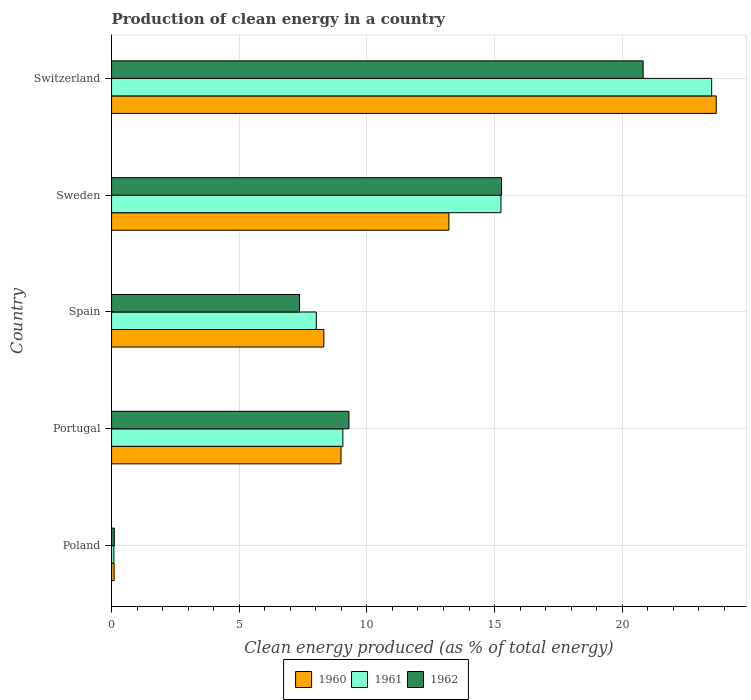How many bars are there on the 2nd tick from the top?
Your response must be concise. 3. In how many cases, is the number of bars for a given country not equal to the number of legend labels?
Your answer should be compact. 0. What is the percentage of clean energy produced in 1960 in Poland?
Provide a short and direct response. 0.1. Across all countries, what is the maximum percentage of clean energy produced in 1960?
Offer a terse response. 23.68. Across all countries, what is the minimum percentage of clean energy produced in 1961?
Your answer should be very brief. 0.09. In which country was the percentage of clean energy produced in 1960 maximum?
Provide a short and direct response. Switzerland. What is the total percentage of clean energy produced in 1960 in the graph?
Keep it short and to the point. 54.29. What is the difference between the percentage of clean energy produced in 1962 in Portugal and that in Sweden?
Keep it short and to the point. -5.98. What is the difference between the percentage of clean energy produced in 1962 in Poland and the percentage of clean energy produced in 1961 in Sweden?
Give a very brief answer. -15.14. What is the average percentage of clean energy produced in 1960 per country?
Your response must be concise. 10.86. What is the difference between the percentage of clean energy produced in 1961 and percentage of clean energy produced in 1962 in Switzerland?
Provide a short and direct response. 2.68. In how many countries, is the percentage of clean energy produced in 1960 greater than 15 %?
Give a very brief answer. 1. What is the ratio of the percentage of clean energy produced in 1961 in Poland to that in Switzerland?
Make the answer very short. 0. Is the difference between the percentage of clean energy produced in 1961 in Portugal and Switzerland greater than the difference between the percentage of clean energy produced in 1962 in Portugal and Switzerland?
Your answer should be compact. No. What is the difference between the highest and the second highest percentage of clean energy produced in 1960?
Provide a succinct answer. 10.47. What is the difference between the highest and the lowest percentage of clean energy produced in 1961?
Your response must be concise. 23.41. In how many countries, is the percentage of clean energy produced in 1962 greater than the average percentage of clean energy produced in 1962 taken over all countries?
Give a very brief answer. 2. What does the 3rd bar from the bottom in Switzerland represents?
Make the answer very short. 1962. Is it the case that in every country, the sum of the percentage of clean energy produced in 1962 and percentage of clean energy produced in 1960 is greater than the percentage of clean energy produced in 1961?
Your response must be concise. Yes. Are all the bars in the graph horizontal?
Offer a terse response. Yes. How many countries are there in the graph?
Offer a terse response. 5. What is the difference between two consecutive major ticks on the X-axis?
Provide a short and direct response. 5. Are the values on the major ticks of X-axis written in scientific E-notation?
Offer a terse response. No. Does the graph contain grids?
Give a very brief answer. Yes. Where does the legend appear in the graph?
Your answer should be compact. Bottom center. How many legend labels are there?
Your response must be concise. 3. How are the legend labels stacked?
Provide a short and direct response. Horizontal. What is the title of the graph?
Your response must be concise. Production of clean energy in a country. Does "1997" appear as one of the legend labels in the graph?
Ensure brevity in your answer.  No. What is the label or title of the X-axis?
Your answer should be compact. Clean energy produced (as % of total energy). What is the Clean energy produced (as % of total energy) in 1960 in Poland?
Make the answer very short. 0.1. What is the Clean energy produced (as % of total energy) of 1961 in Poland?
Offer a terse response. 0.09. What is the Clean energy produced (as % of total energy) in 1962 in Poland?
Your answer should be compact. 0.11. What is the Clean energy produced (as % of total energy) in 1960 in Portugal?
Offer a very short reply. 8.99. What is the Clean energy produced (as % of total energy) in 1961 in Portugal?
Keep it short and to the point. 9.06. What is the Clean energy produced (as % of total energy) of 1962 in Portugal?
Give a very brief answer. 9.3. What is the Clean energy produced (as % of total energy) of 1960 in Spain?
Provide a succinct answer. 8.31. What is the Clean energy produced (as % of total energy) of 1961 in Spain?
Keep it short and to the point. 8.02. What is the Clean energy produced (as % of total energy) of 1962 in Spain?
Ensure brevity in your answer.  7.36. What is the Clean energy produced (as % of total energy) in 1960 in Sweden?
Provide a short and direct response. 13.21. What is the Clean energy produced (as % of total energy) of 1961 in Sweden?
Give a very brief answer. 15.25. What is the Clean energy produced (as % of total energy) of 1962 in Sweden?
Make the answer very short. 15.27. What is the Clean energy produced (as % of total energy) of 1960 in Switzerland?
Your answer should be very brief. 23.68. What is the Clean energy produced (as % of total energy) in 1961 in Switzerland?
Your response must be concise. 23.5. What is the Clean energy produced (as % of total energy) in 1962 in Switzerland?
Your response must be concise. 20.82. Across all countries, what is the maximum Clean energy produced (as % of total energy) of 1960?
Ensure brevity in your answer.  23.68. Across all countries, what is the maximum Clean energy produced (as % of total energy) in 1961?
Ensure brevity in your answer.  23.5. Across all countries, what is the maximum Clean energy produced (as % of total energy) of 1962?
Make the answer very short. 20.82. Across all countries, what is the minimum Clean energy produced (as % of total energy) in 1960?
Ensure brevity in your answer.  0.1. Across all countries, what is the minimum Clean energy produced (as % of total energy) in 1961?
Make the answer very short. 0.09. Across all countries, what is the minimum Clean energy produced (as % of total energy) in 1962?
Give a very brief answer. 0.11. What is the total Clean energy produced (as % of total energy) in 1960 in the graph?
Your response must be concise. 54.29. What is the total Clean energy produced (as % of total energy) of 1961 in the graph?
Your answer should be compact. 55.92. What is the total Clean energy produced (as % of total energy) of 1962 in the graph?
Offer a terse response. 52.86. What is the difference between the Clean energy produced (as % of total energy) in 1960 in Poland and that in Portugal?
Provide a short and direct response. -8.88. What is the difference between the Clean energy produced (as % of total energy) of 1961 in Poland and that in Portugal?
Make the answer very short. -8.97. What is the difference between the Clean energy produced (as % of total energy) in 1962 in Poland and that in Portugal?
Provide a succinct answer. -9.19. What is the difference between the Clean energy produced (as % of total energy) of 1960 in Poland and that in Spain?
Ensure brevity in your answer.  -8.21. What is the difference between the Clean energy produced (as % of total energy) of 1961 in Poland and that in Spain?
Offer a terse response. -7.93. What is the difference between the Clean energy produced (as % of total energy) of 1962 in Poland and that in Spain?
Your answer should be compact. -7.25. What is the difference between the Clean energy produced (as % of total energy) of 1960 in Poland and that in Sweden?
Make the answer very short. -13.11. What is the difference between the Clean energy produced (as % of total energy) in 1961 in Poland and that in Sweden?
Give a very brief answer. -15.16. What is the difference between the Clean energy produced (as % of total energy) of 1962 in Poland and that in Sweden?
Your response must be concise. -15.17. What is the difference between the Clean energy produced (as % of total energy) of 1960 in Poland and that in Switzerland?
Give a very brief answer. -23.58. What is the difference between the Clean energy produced (as % of total energy) of 1961 in Poland and that in Switzerland?
Offer a very short reply. -23.41. What is the difference between the Clean energy produced (as % of total energy) in 1962 in Poland and that in Switzerland?
Offer a terse response. -20.71. What is the difference between the Clean energy produced (as % of total energy) in 1960 in Portugal and that in Spain?
Offer a very short reply. 0.67. What is the difference between the Clean energy produced (as % of total energy) of 1961 in Portugal and that in Spain?
Your response must be concise. 1.04. What is the difference between the Clean energy produced (as % of total energy) of 1962 in Portugal and that in Spain?
Keep it short and to the point. 1.94. What is the difference between the Clean energy produced (as % of total energy) of 1960 in Portugal and that in Sweden?
Your response must be concise. -4.23. What is the difference between the Clean energy produced (as % of total energy) in 1961 in Portugal and that in Sweden?
Offer a very short reply. -6.19. What is the difference between the Clean energy produced (as % of total energy) of 1962 in Portugal and that in Sweden?
Make the answer very short. -5.98. What is the difference between the Clean energy produced (as % of total energy) of 1960 in Portugal and that in Switzerland?
Ensure brevity in your answer.  -14.7. What is the difference between the Clean energy produced (as % of total energy) of 1961 in Portugal and that in Switzerland?
Offer a terse response. -14.44. What is the difference between the Clean energy produced (as % of total energy) of 1962 in Portugal and that in Switzerland?
Offer a terse response. -11.52. What is the difference between the Clean energy produced (as % of total energy) of 1960 in Spain and that in Sweden?
Your response must be concise. -4.9. What is the difference between the Clean energy produced (as % of total energy) of 1961 in Spain and that in Sweden?
Your answer should be very brief. -7.23. What is the difference between the Clean energy produced (as % of total energy) in 1962 in Spain and that in Sweden?
Offer a very short reply. -7.91. What is the difference between the Clean energy produced (as % of total energy) in 1960 in Spain and that in Switzerland?
Your answer should be compact. -15.37. What is the difference between the Clean energy produced (as % of total energy) of 1961 in Spain and that in Switzerland?
Ensure brevity in your answer.  -15.48. What is the difference between the Clean energy produced (as % of total energy) of 1962 in Spain and that in Switzerland?
Give a very brief answer. -13.46. What is the difference between the Clean energy produced (as % of total energy) of 1960 in Sweden and that in Switzerland?
Your answer should be compact. -10.47. What is the difference between the Clean energy produced (as % of total energy) in 1961 in Sweden and that in Switzerland?
Provide a succinct answer. -8.25. What is the difference between the Clean energy produced (as % of total energy) of 1962 in Sweden and that in Switzerland?
Provide a short and direct response. -5.55. What is the difference between the Clean energy produced (as % of total energy) of 1960 in Poland and the Clean energy produced (as % of total energy) of 1961 in Portugal?
Keep it short and to the point. -8.96. What is the difference between the Clean energy produced (as % of total energy) in 1960 in Poland and the Clean energy produced (as % of total energy) in 1962 in Portugal?
Give a very brief answer. -9.2. What is the difference between the Clean energy produced (as % of total energy) of 1961 in Poland and the Clean energy produced (as % of total energy) of 1962 in Portugal?
Make the answer very short. -9.21. What is the difference between the Clean energy produced (as % of total energy) in 1960 in Poland and the Clean energy produced (as % of total energy) in 1961 in Spain?
Your response must be concise. -7.92. What is the difference between the Clean energy produced (as % of total energy) of 1960 in Poland and the Clean energy produced (as % of total energy) of 1962 in Spain?
Provide a succinct answer. -7.26. What is the difference between the Clean energy produced (as % of total energy) in 1961 in Poland and the Clean energy produced (as % of total energy) in 1962 in Spain?
Give a very brief answer. -7.27. What is the difference between the Clean energy produced (as % of total energy) of 1960 in Poland and the Clean energy produced (as % of total energy) of 1961 in Sweden?
Offer a terse response. -15.15. What is the difference between the Clean energy produced (as % of total energy) of 1960 in Poland and the Clean energy produced (as % of total energy) of 1962 in Sweden?
Make the answer very short. -15.17. What is the difference between the Clean energy produced (as % of total energy) of 1961 in Poland and the Clean energy produced (as % of total energy) of 1962 in Sweden?
Make the answer very short. -15.18. What is the difference between the Clean energy produced (as % of total energy) in 1960 in Poland and the Clean energy produced (as % of total energy) in 1961 in Switzerland?
Keep it short and to the point. -23.4. What is the difference between the Clean energy produced (as % of total energy) in 1960 in Poland and the Clean energy produced (as % of total energy) in 1962 in Switzerland?
Your answer should be compact. -20.72. What is the difference between the Clean energy produced (as % of total energy) of 1961 in Poland and the Clean energy produced (as % of total energy) of 1962 in Switzerland?
Ensure brevity in your answer.  -20.73. What is the difference between the Clean energy produced (as % of total energy) of 1960 in Portugal and the Clean energy produced (as % of total energy) of 1961 in Spain?
Provide a short and direct response. 0.97. What is the difference between the Clean energy produced (as % of total energy) in 1960 in Portugal and the Clean energy produced (as % of total energy) in 1962 in Spain?
Your answer should be very brief. 1.62. What is the difference between the Clean energy produced (as % of total energy) in 1961 in Portugal and the Clean energy produced (as % of total energy) in 1962 in Spain?
Ensure brevity in your answer.  1.7. What is the difference between the Clean energy produced (as % of total energy) in 1960 in Portugal and the Clean energy produced (as % of total energy) in 1961 in Sweden?
Ensure brevity in your answer.  -6.26. What is the difference between the Clean energy produced (as % of total energy) in 1960 in Portugal and the Clean energy produced (as % of total energy) in 1962 in Sweden?
Your answer should be very brief. -6.29. What is the difference between the Clean energy produced (as % of total energy) of 1961 in Portugal and the Clean energy produced (as % of total energy) of 1962 in Sweden?
Provide a succinct answer. -6.21. What is the difference between the Clean energy produced (as % of total energy) of 1960 in Portugal and the Clean energy produced (as % of total energy) of 1961 in Switzerland?
Offer a very short reply. -14.52. What is the difference between the Clean energy produced (as % of total energy) of 1960 in Portugal and the Clean energy produced (as % of total energy) of 1962 in Switzerland?
Your response must be concise. -11.83. What is the difference between the Clean energy produced (as % of total energy) in 1961 in Portugal and the Clean energy produced (as % of total energy) in 1962 in Switzerland?
Offer a very short reply. -11.76. What is the difference between the Clean energy produced (as % of total energy) in 1960 in Spain and the Clean energy produced (as % of total energy) in 1961 in Sweden?
Make the answer very short. -6.94. What is the difference between the Clean energy produced (as % of total energy) in 1960 in Spain and the Clean energy produced (as % of total energy) in 1962 in Sweden?
Make the answer very short. -6.96. What is the difference between the Clean energy produced (as % of total energy) in 1961 in Spain and the Clean energy produced (as % of total energy) in 1962 in Sweden?
Give a very brief answer. -7.26. What is the difference between the Clean energy produced (as % of total energy) of 1960 in Spain and the Clean energy produced (as % of total energy) of 1961 in Switzerland?
Make the answer very short. -15.19. What is the difference between the Clean energy produced (as % of total energy) in 1960 in Spain and the Clean energy produced (as % of total energy) in 1962 in Switzerland?
Offer a very short reply. -12.5. What is the difference between the Clean energy produced (as % of total energy) of 1961 in Spain and the Clean energy produced (as % of total energy) of 1962 in Switzerland?
Your response must be concise. -12.8. What is the difference between the Clean energy produced (as % of total energy) in 1960 in Sweden and the Clean energy produced (as % of total energy) in 1961 in Switzerland?
Offer a very short reply. -10.29. What is the difference between the Clean energy produced (as % of total energy) of 1960 in Sweden and the Clean energy produced (as % of total energy) of 1962 in Switzerland?
Ensure brevity in your answer.  -7.61. What is the difference between the Clean energy produced (as % of total energy) of 1961 in Sweden and the Clean energy produced (as % of total energy) of 1962 in Switzerland?
Provide a short and direct response. -5.57. What is the average Clean energy produced (as % of total energy) in 1960 per country?
Offer a terse response. 10.86. What is the average Clean energy produced (as % of total energy) in 1961 per country?
Offer a terse response. 11.18. What is the average Clean energy produced (as % of total energy) of 1962 per country?
Your response must be concise. 10.57. What is the difference between the Clean energy produced (as % of total energy) in 1960 and Clean energy produced (as % of total energy) in 1961 in Poland?
Make the answer very short. 0.01. What is the difference between the Clean energy produced (as % of total energy) of 1960 and Clean energy produced (as % of total energy) of 1962 in Poland?
Give a very brief answer. -0.01. What is the difference between the Clean energy produced (as % of total energy) of 1961 and Clean energy produced (as % of total energy) of 1962 in Poland?
Provide a succinct answer. -0.02. What is the difference between the Clean energy produced (as % of total energy) of 1960 and Clean energy produced (as % of total energy) of 1961 in Portugal?
Your answer should be very brief. -0.07. What is the difference between the Clean energy produced (as % of total energy) in 1960 and Clean energy produced (as % of total energy) in 1962 in Portugal?
Offer a very short reply. -0.31. What is the difference between the Clean energy produced (as % of total energy) of 1961 and Clean energy produced (as % of total energy) of 1962 in Portugal?
Provide a succinct answer. -0.24. What is the difference between the Clean energy produced (as % of total energy) in 1960 and Clean energy produced (as % of total energy) in 1961 in Spain?
Keep it short and to the point. 0.3. What is the difference between the Clean energy produced (as % of total energy) in 1960 and Clean energy produced (as % of total energy) in 1962 in Spain?
Your response must be concise. 0.95. What is the difference between the Clean energy produced (as % of total energy) of 1961 and Clean energy produced (as % of total energy) of 1962 in Spain?
Give a very brief answer. 0.66. What is the difference between the Clean energy produced (as % of total energy) in 1960 and Clean energy produced (as % of total energy) in 1961 in Sweden?
Keep it short and to the point. -2.04. What is the difference between the Clean energy produced (as % of total energy) of 1960 and Clean energy produced (as % of total energy) of 1962 in Sweden?
Your answer should be very brief. -2.06. What is the difference between the Clean energy produced (as % of total energy) of 1961 and Clean energy produced (as % of total energy) of 1962 in Sweden?
Ensure brevity in your answer.  -0.02. What is the difference between the Clean energy produced (as % of total energy) in 1960 and Clean energy produced (as % of total energy) in 1961 in Switzerland?
Your answer should be very brief. 0.18. What is the difference between the Clean energy produced (as % of total energy) of 1960 and Clean energy produced (as % of total energy) of 1962 in Switzerland?
Keep it short and to the point. 2.86. What is the difference between the Clean energy produced (as % of total energy) in 1961 and Clean energy produced (as % of total energy) in 1962 in Switzerland?
Provide a succinct answer. 2.68. What is the ratio of the Clean energy produced (as % of total energy) in 1960 in Poland to that in Portugal?
Ensure brevity in your answer.  0.01. What is the ratio of the Clean energy produced (as % of total energy) of 1961 in Poland to that in Portugal?
Keep it short and to the point. 0.01. What is the ratio of the Clean energy produced (as % of total energy) in 1962 in Poland to that in Portugal?
Ensure brevity in your answer.  0.01. What is the ratio of the Clean energy produced (as % of total energy) of 1960 in Poland to that in Spain?
Offer a very short reply. 0.01. What is the ratio of the Clean energy produced (as % of total energy) of 1961 in Poland to that in Spain?
Keep it short and to the point. 0.01. What is the ratio of the Clean energy produced (as % of total energy) in 1962 in Poland to that in Spain?
Give a very brief answer. 0.01. What is the ratio of the Clean energy produced (as % of total energy) of 1960 in Poland to that in Sweden?
Your answer should be very brief. 0.01. What is the ratio of the Clean energy produced (as % of total energy) in 1961 in Poland to that in Sweden?
Ensure brevity in your answer.  0.01. What is the ratio of the Clean energy produced (as % of total energy) of 1962 in Poland to that in Sweden?
Ensure brevity in your answer.  0.01. What is the ratio of the Clean energy produced (as % of total energy) of 1960 in Poland to that in Switzerland?
Give a very brief answer. 0. What is the ratio of the Clean energy produced (as % of total energy) in 1961 in Poland to that in Switzerland?
Your answer should be compact. 0. What is the ratio of the Clean energy produced (as % of total energy) of 1962 in Poland to that in Switzerland?
Your answer should be very brief. 0.01. What is the ratio of the Clean energy produced (as % of total energy) in 1960 in Portugal to that in Spain?
Offer a very short reply. 1.08. What is the ratio of the Clean energy produced (as % of total energy) of 1961 in Portugal to that in Spain?
Your answer should be compact. 1.13. What is the ratio of the Clean energy produced (as % of total energy) in 1962 in Portugal to that in Spain?
Keep it short and to the point. 1.26. What is the ratio of the Clean energy produced (as % of total energy) in 1960 in Portugal to that in Sweden?
Keep it short and to the point. 0.68. What is the ratio of the Clean energy produced (as % of total energy) in 1961 in Portugal to that in Sweden?
Make the answer very short. 0.59. What is the ratio of the Clean energy produced (as % of total energy) in 1962 in Portugal to that in Sweden?
Your answer should be compact. 0.61. What is the ratio of the Clean energy produced (as % of total energy) in 1960 in Portugal to that in Switzerland?
Ensure brevity in your answer.  0.38. What is the ratio of the Clean energy produced (as % of total energy) in 1961 in Portugal to that in Switzerland?
Your answer should be very brief. 0.39. What is the ratio of the Clean energy produced (as % of total energy) in 1962 in Portugal to that in Switzerland?
Keep it short and to the point. 0.45. What is the ratio of the Clean energy produced (as % of total energy) in 1960 in Spain to that in Sweden?
Give a very brief answer. 0.63. What is the ratio of the Clean energy produced (as % of total energy) in 1961 in Spain to that in Sweden?
Provide a short and direct response. 0.53. What is the ratio of the Clean energy produced (as % of total energy) in 1962 in Spain to that in Sweden?
Provide a short and direct response. 0.48. What is the ratio of the Clean energy produced (as % of total energy) of 1960 in Spain to that in Switzerland?
Your answer should be very brief. 0.35. What is the ratio of the Clean energy produced (as % of total energy) in 1961 in Spain to that in Switzerland?
Offer a very short reply. 0.34. What is the ratio of the Clean energy produced (as % of total energy) of 1962 in Spain to that in Switzerland?
Keep it short and to the point. 0.35. What is the ratio of the Clean energy produced (as % of total energy) in 1960 in Sweden to that in Switzerland?
Ensure brevity in your answer.  0.56. What is the ratio of the Clean energy produced (as % of total energy) of 1961 in Sweden to that in Switzerland?
Keep it short and to the point. 0.65. What is the ratio of the Clean energy produced (as % of total energy) of 1962 in Sweden to that in Switzerland?
Your response must be concise. 0.73. What is the difference between the highest and the second highest Clean energy produced (as % of total energy) of 1960?
Keep it short and to the point. 10.47. What is the difference between the highest and the second highest Clean energy produced (as % of total energy) of 1961?
Make the answer very short. 8.25. What is the difference between the highest and the second highest Clean energy produced (as % of total energy) of 1962?
Ensure brevity in your answer.  5.55. What is the difference between the highest and the lowest Clean energy produced (as % of total energy) in 1960?
Your response must be concise. 23.58. What is the difference between the highest and the lowest Clean energy produced (as % of total energy) of 1961?
Offer a very short reply. 23.41. What is the difference between the highest and the lowest Clean energy produced (as % of total energy) in 1962?
Give a very brief answer. 20.71. 